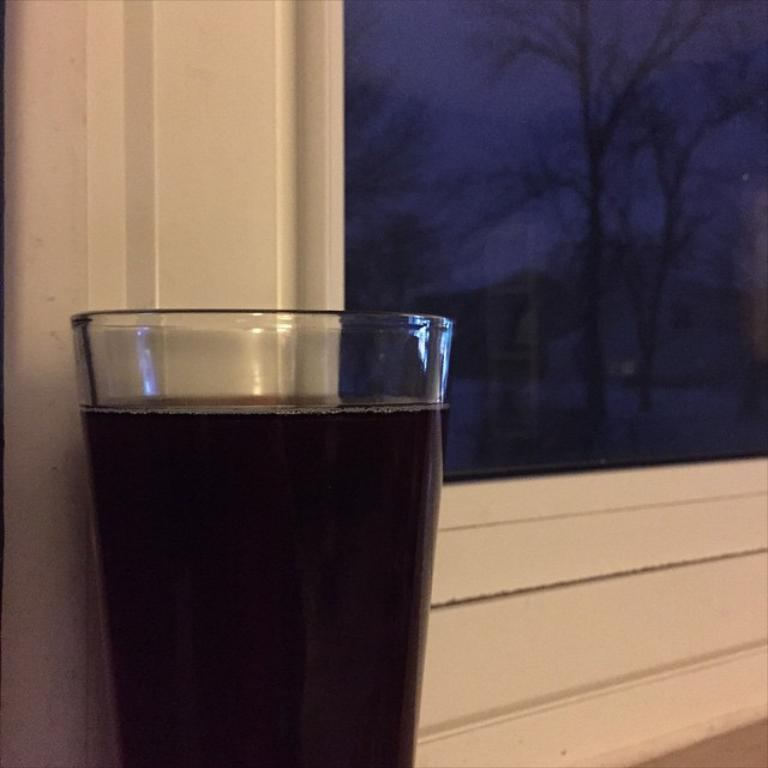What object is visible in the image? There is a glass in the image. Where is the glass located in relation to other elements in the image? The glass is in front of a window. What type of motion can be observed in the glass in the image? There is no motion observed in the glass in the image; it is stationary. What is the mass of the glass in the image? The mass of the glass cannot be determined from the image alone. 